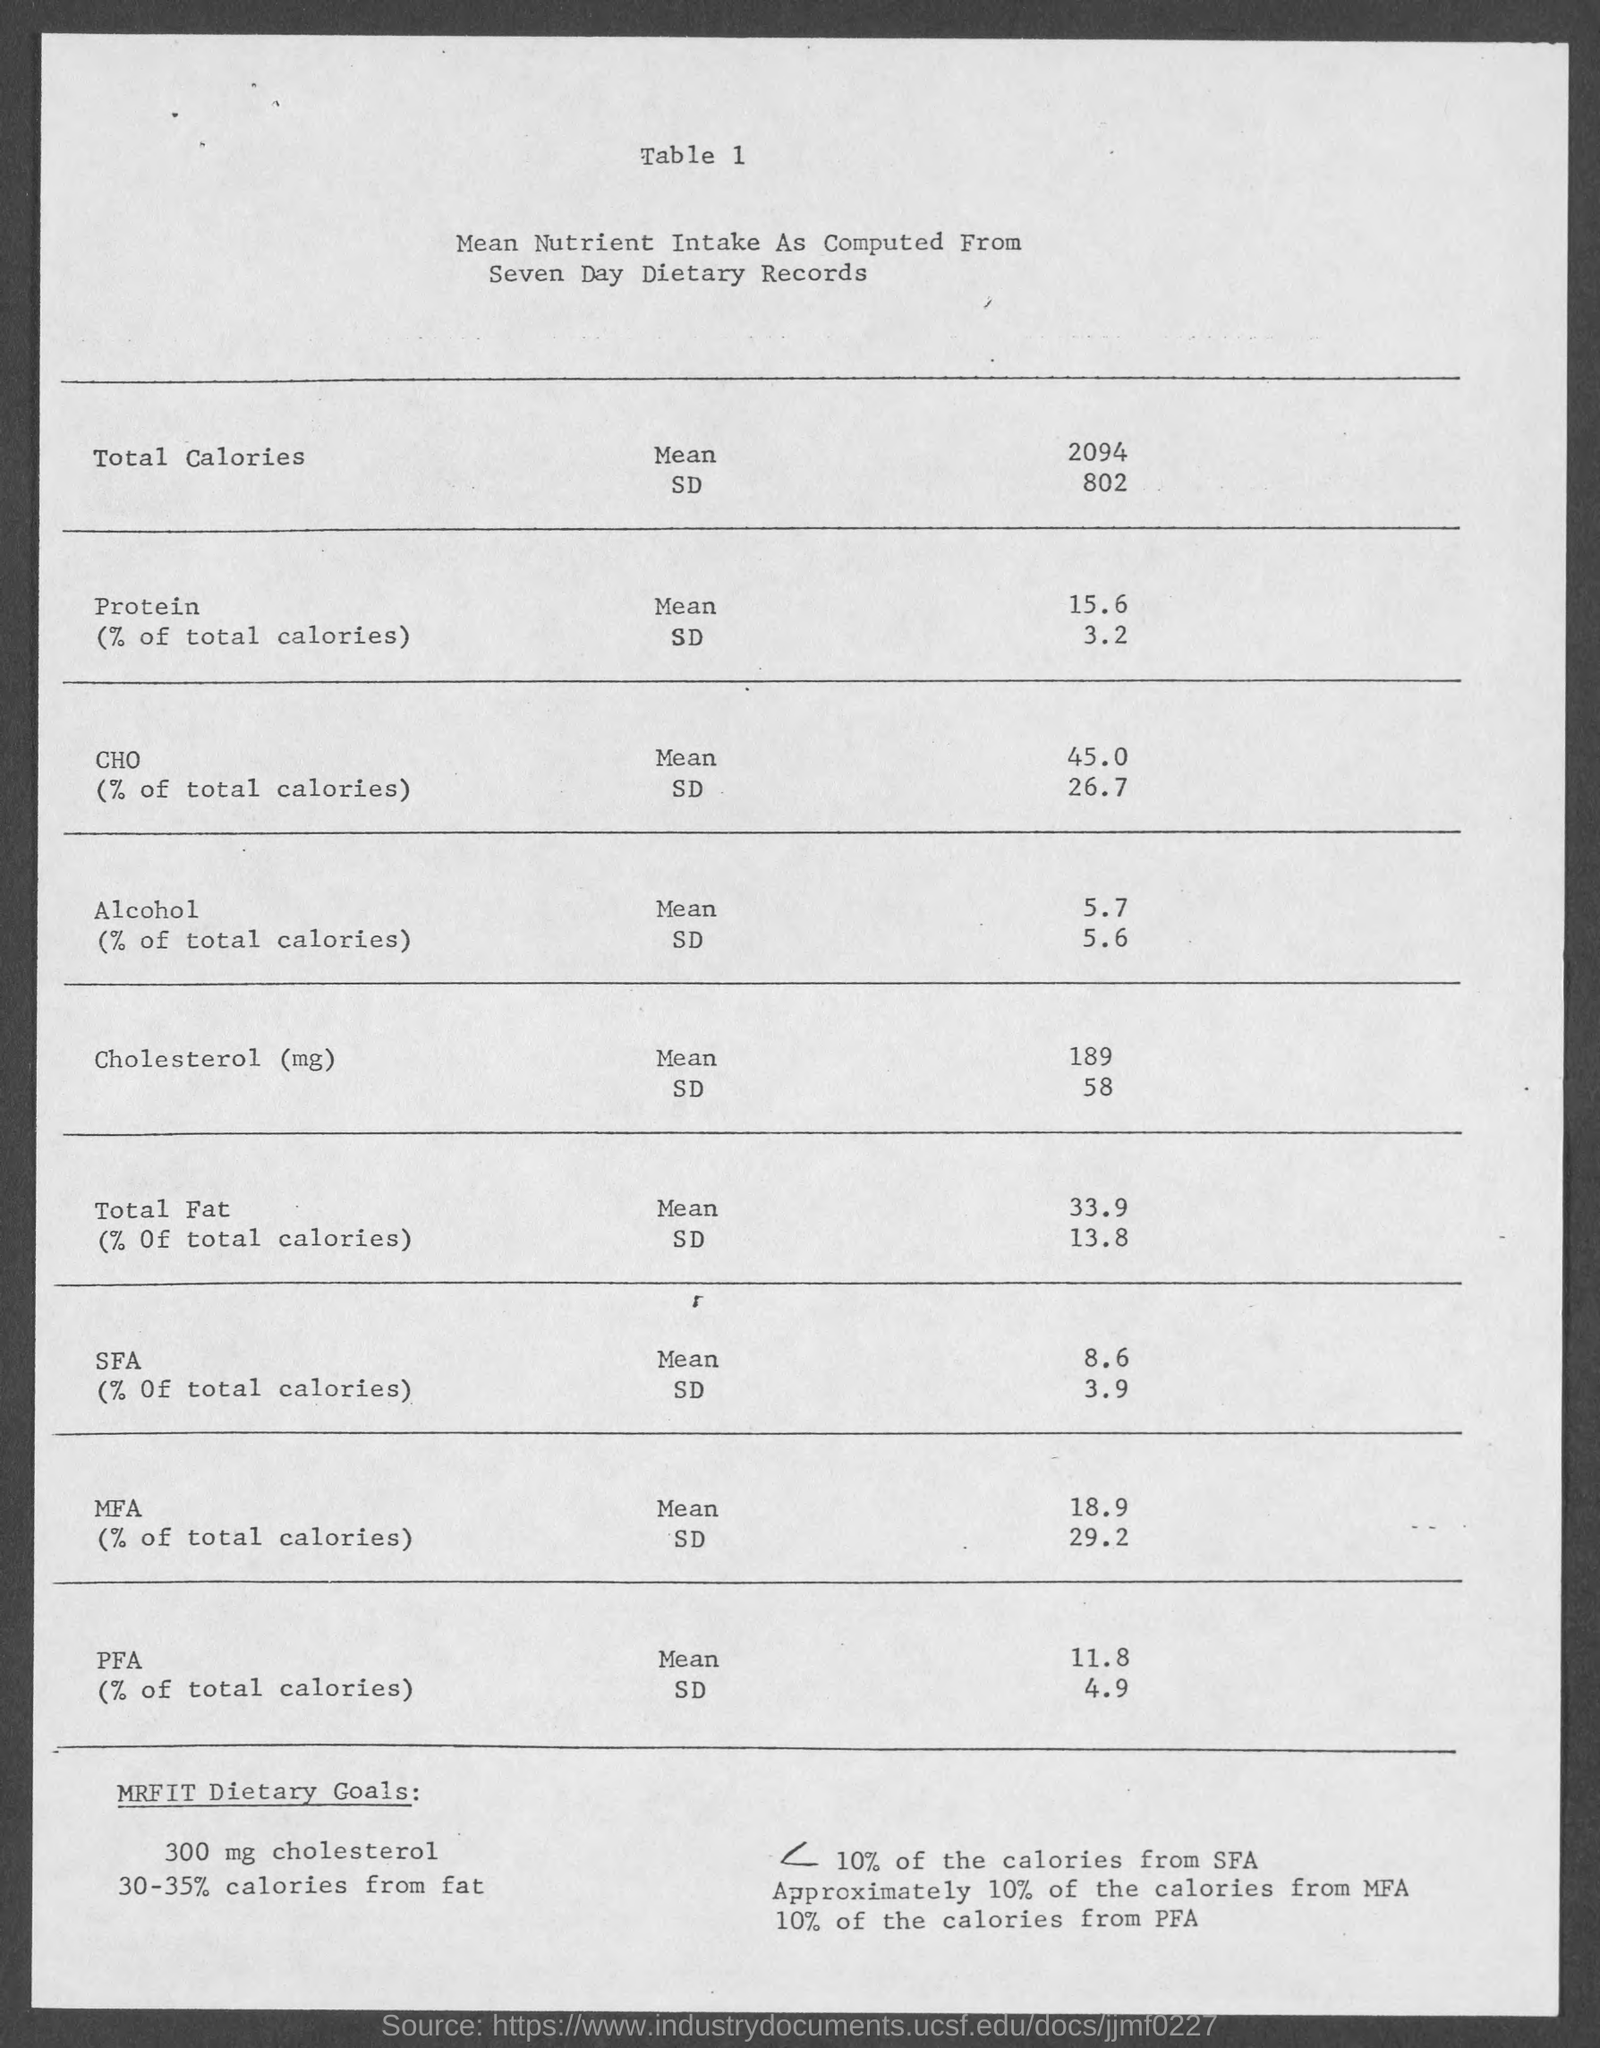List a handful of essential elements in this visual. The mean intake of protein as a percentage of total calories is 15.6%. The mean intake value of alcohol mentioned in the given table is 5.7. The mean intake of total calories is 2094. The daily intake of carbohydrates as a percentage of total calories is typically 45%. The standard deviation (SD) value of the protein mentioned in the given table is 3.2. 